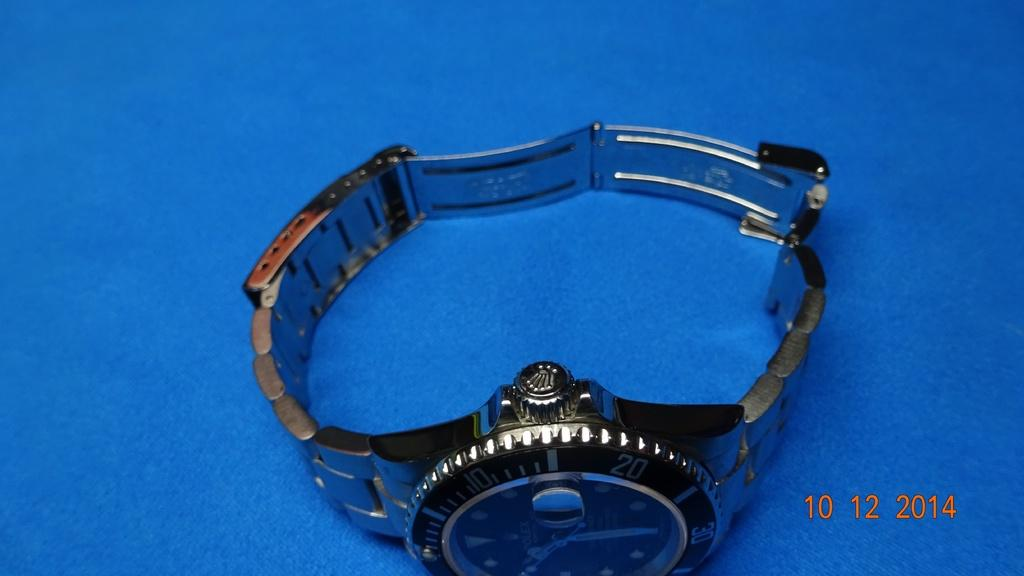<image>
Share a concise interpretation of the image provided. A photo of a Rolex watch was taken in 2014. 